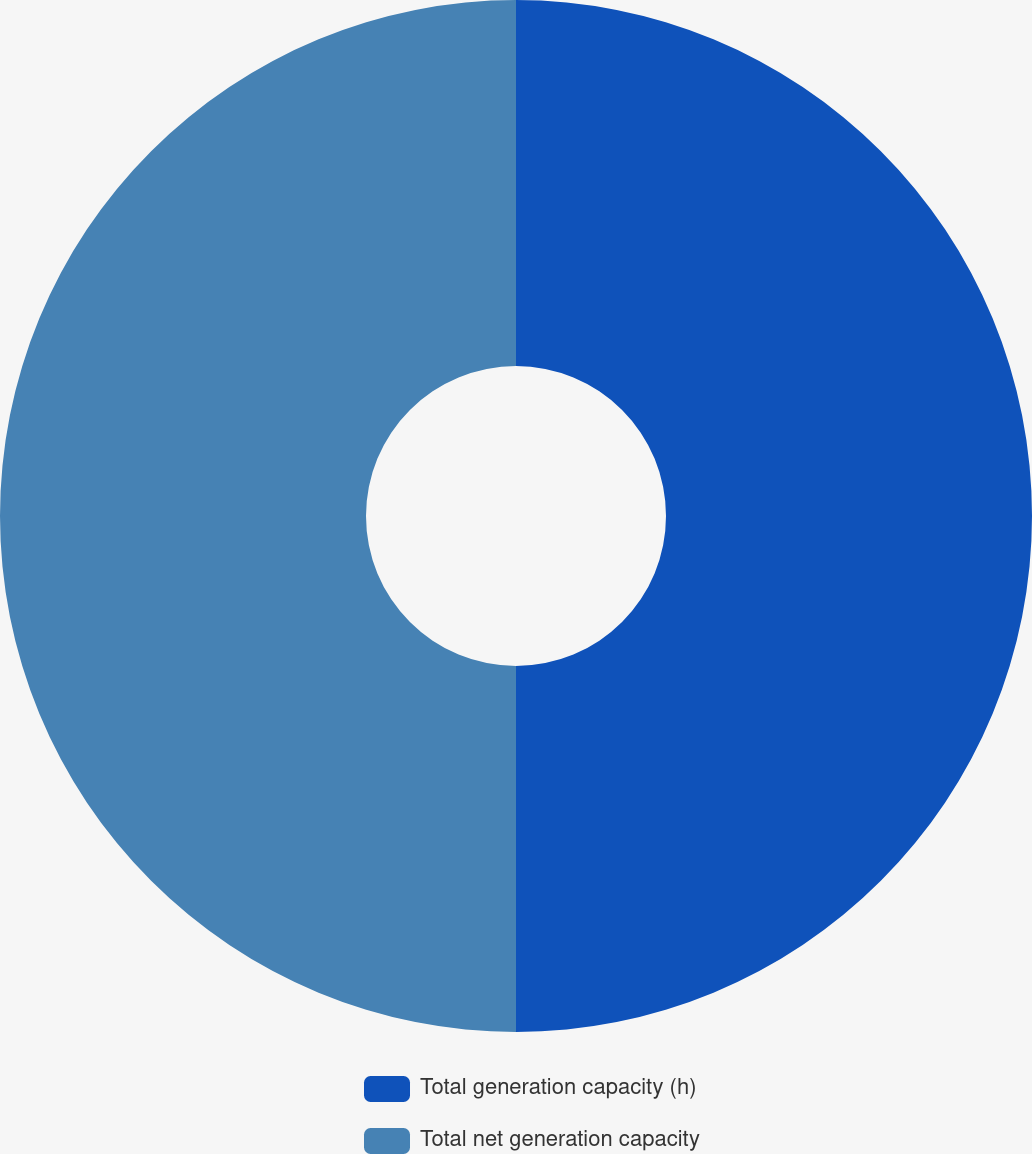<chart> <loc_0><loc_0><loc_500><loc_500><pie_chart><fcel>Total generation capacity (h)<fcel>Total net generation capacity<nl><fcel>50.0%<fcel>50.0%<nl></chart> 